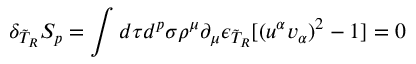Convert formula to latex. <formula><loc_0><loc_0><loc_500><loc_500>\delta _ { \tilde { T } _ { R } } S _ { p } = \int d \tau d ^ { p } \sigma \rho ^ { \mu } \partial _ { \mu } \epsilon _ { \tilde { T } _ { R } } [ ( u ^ { \alpha } v _ { \alpha } ) ^ { 2 } - 1 ] = 0</formula> 